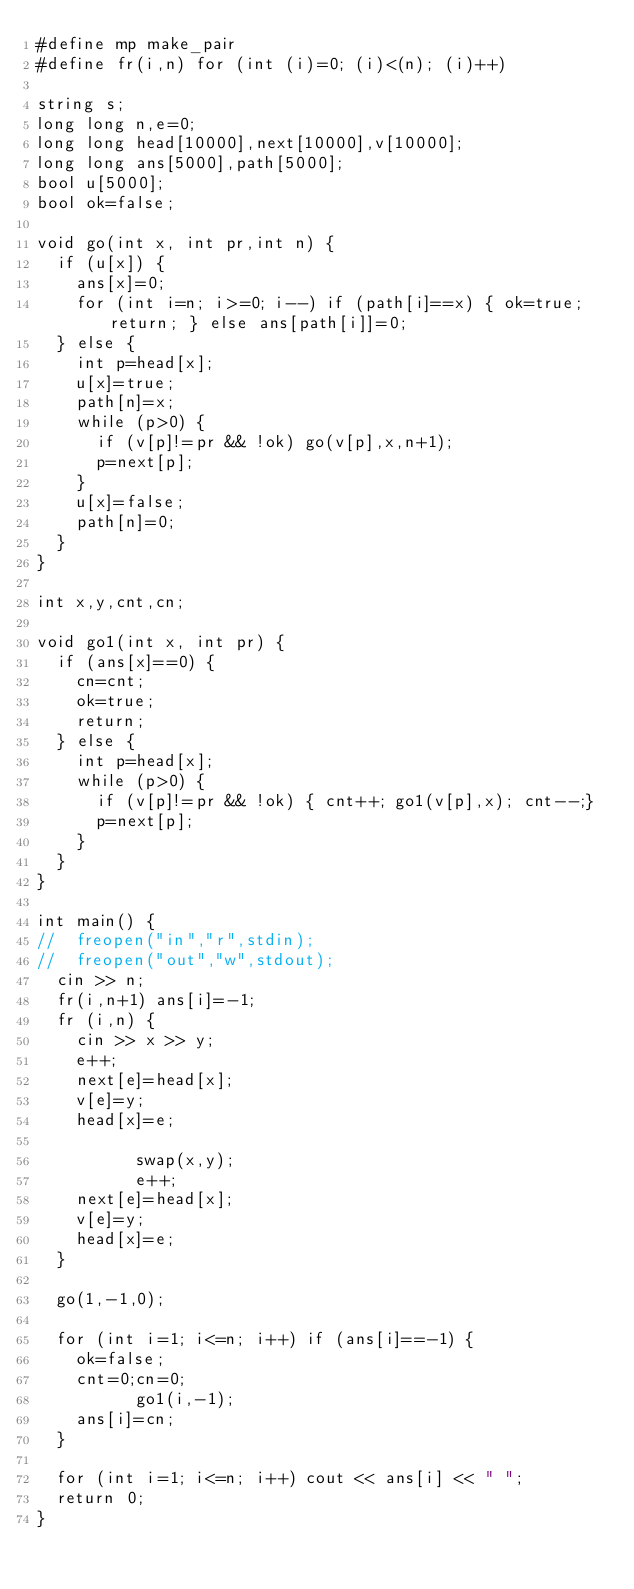Convert code to text. <code><loc_0><loc_0><loc_500><loc_500><_C++_>#define mp make_pair
#define fr(i,n) for (int (i)=0; (i)<(n); (i)++)

string s; 
long long n,e=0;
long long head[10000],next[10000],v[10000];
long long ans[5000],path[5000];
bool u[5000]; 
bool ok=false; 

void go(int x, int pr,int n) {
	if (u[x]) {
		ans[x]=0; 
		for (int i=n; i>=0; i--) if (path[i]==x) { ok=true; return; } else ans[path[i]]=0; 
	} else {
		int p=head[x];
		u[x]=true;  
		path[n]=x; 
		while (p>0) {
			if (v[p]!=pr && !ok) go(v[p],x,n+1);
			p=next[p];   
		}
		u[x]=false; 
		path[n]=0;
	}
}

int x,y,cnt,cn; 

void go1(int x, int pr) {
	if (ans[x]==0) {
		cn=cnt;
		ok=true; 
		return;
	} else {
		int p=head[x];
		while (p>0) {
			if (v[p]!=pr && !ok) { cnt++; go1(v[p],x); cnt--;}
			p=next[p];   
		}
	}
}

int main() {
//	freopen("in","r",stdin);
//	freopen("out","w",stdout);
	cin >> n;
	fr(i,n+1) ans[i]=-1; 
	fr (i,n) {
		cin >> x >> y; 
		e++; 
		next[e]=head[x]; 
		v[e]=y; 
		head[x]=e; 

	        swap(x,y);
	        e++; 
		next[e]=head[x]; 
		v[e]=y; 
		head[x]=e;
	}

	go(1,-1,0);

	for (int i=1; i<=n; i++) if (ans[i]==-1) {
		ok=false;  
		cnt=0;cn=0;  
	        go1(i,-1);
		ans[i]=cn; 
	}

	for (int i=1; i<=n; i++) cout << ans[i] << " "; 
	return 0; 
}
</code> 